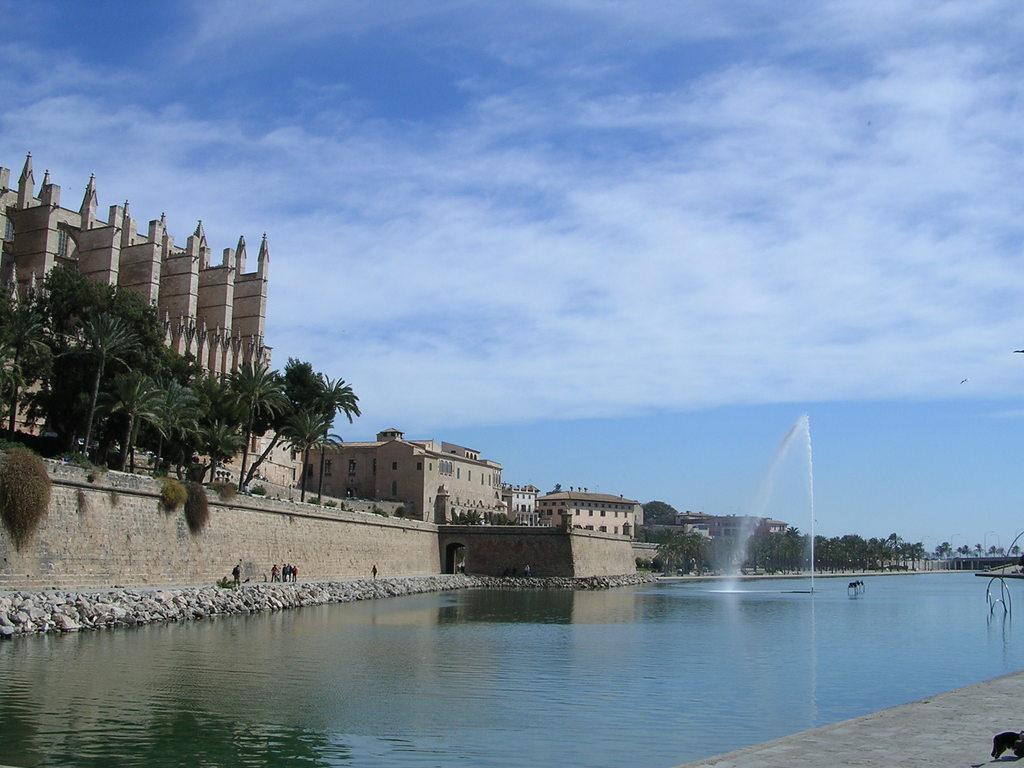What is visible in the image? Water is visible in the image. What can be seen in the background of the image? There are trees and buildings in the background of the image. What is the color of the trees in the background? The trees in the background are green. What is the color of the buildings in the background? The buildings in the background are brown and cream-colored. What is the color of the sky in the image? The sky is blue and white in the image. What type of wax can be seen dripping from the trees in the image? There is no wax present in the image; the trees are green and not dripping any substance. 